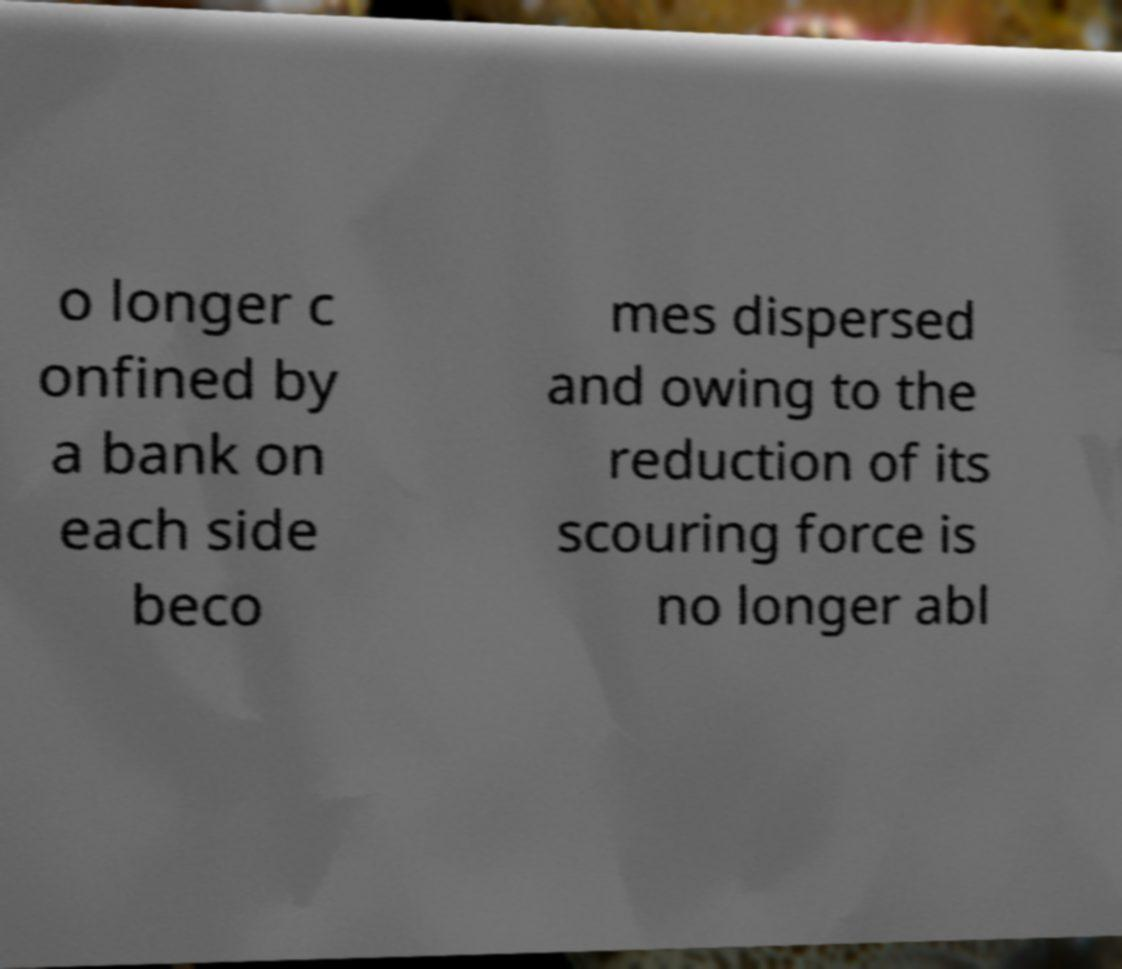Could you extract and type out the text from this image? o longer c onfined by a bank on each side beco mes dispersed and owing to the reduction of its scouring force is no longer abl 